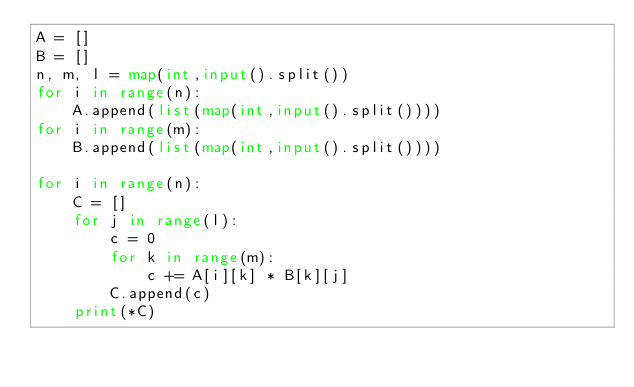Convert code to text. <code><loc_0><loc_0><loc_500><loc_500><_Python_>A = []
B = []
n, m, l = map(int,input().split())
for i in range(n):
    A.append(list(map(int,input().split())))
for i in range(m):
    B.append(list(map(int,input().split())))

for i in range(n):
    C = []
    for j in range(l):
        c = 0
        for k in range(m):
            c += A[i][k] * B[k][j]
        C.append(c)
    print(*C)</code> 